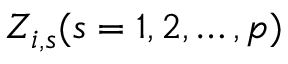Convert formula to latex. <formula><loc_0><loc_0><loc_500><loc_500>Z _ { i , s } ( s = 1 , 2 , \dots , p )</formula> 